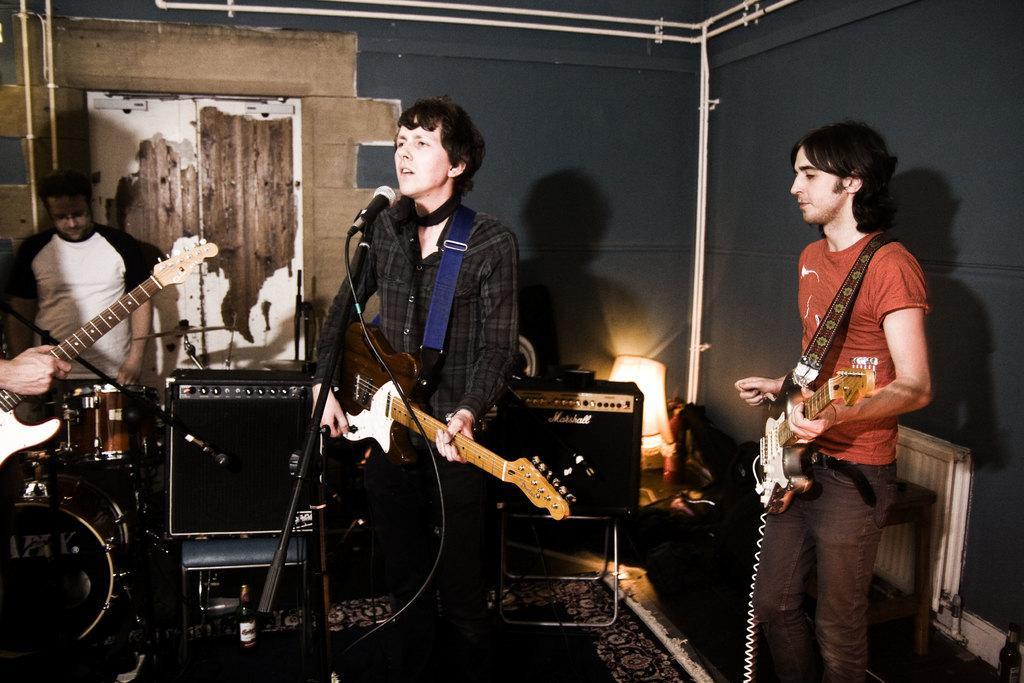Please provide a concise description of this image. Here we can see 3 people playing guitars and the person in the middle is singing a song with microphone in front of him and the person behind him is playing drums and there are other musical instrument present 